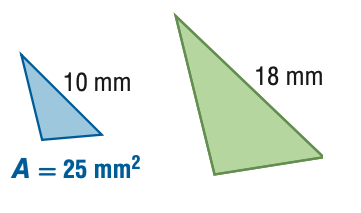Answer the mathemtical geometry problem and directly provide the correct option letter.
Question: For the pair of similar figures, find the area of the green figure.
Choices: A: 7.7 B: 13.9 C: 45 D: 81 D 